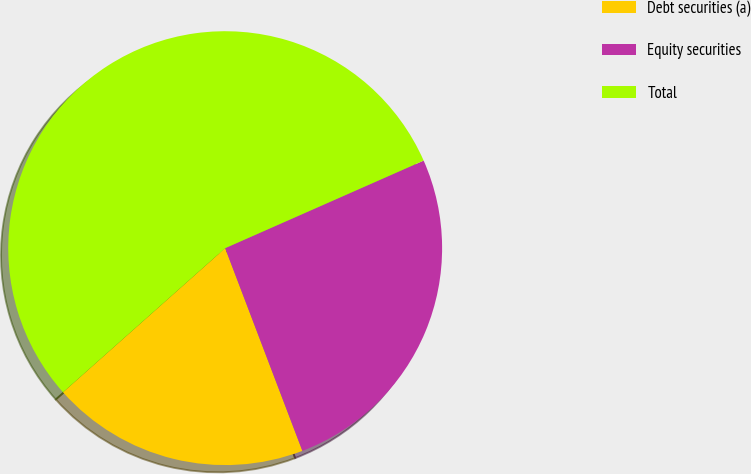Convert chart. <chart><loc_0><loc_0><loc_500><loc_500><pie_chart><fcel>Debt securities (a)<fcel>Equity securities<fcel>Total<nl><fcel>19.23%<fcel>25.82%<fcel>54.95%<nl></chart> 